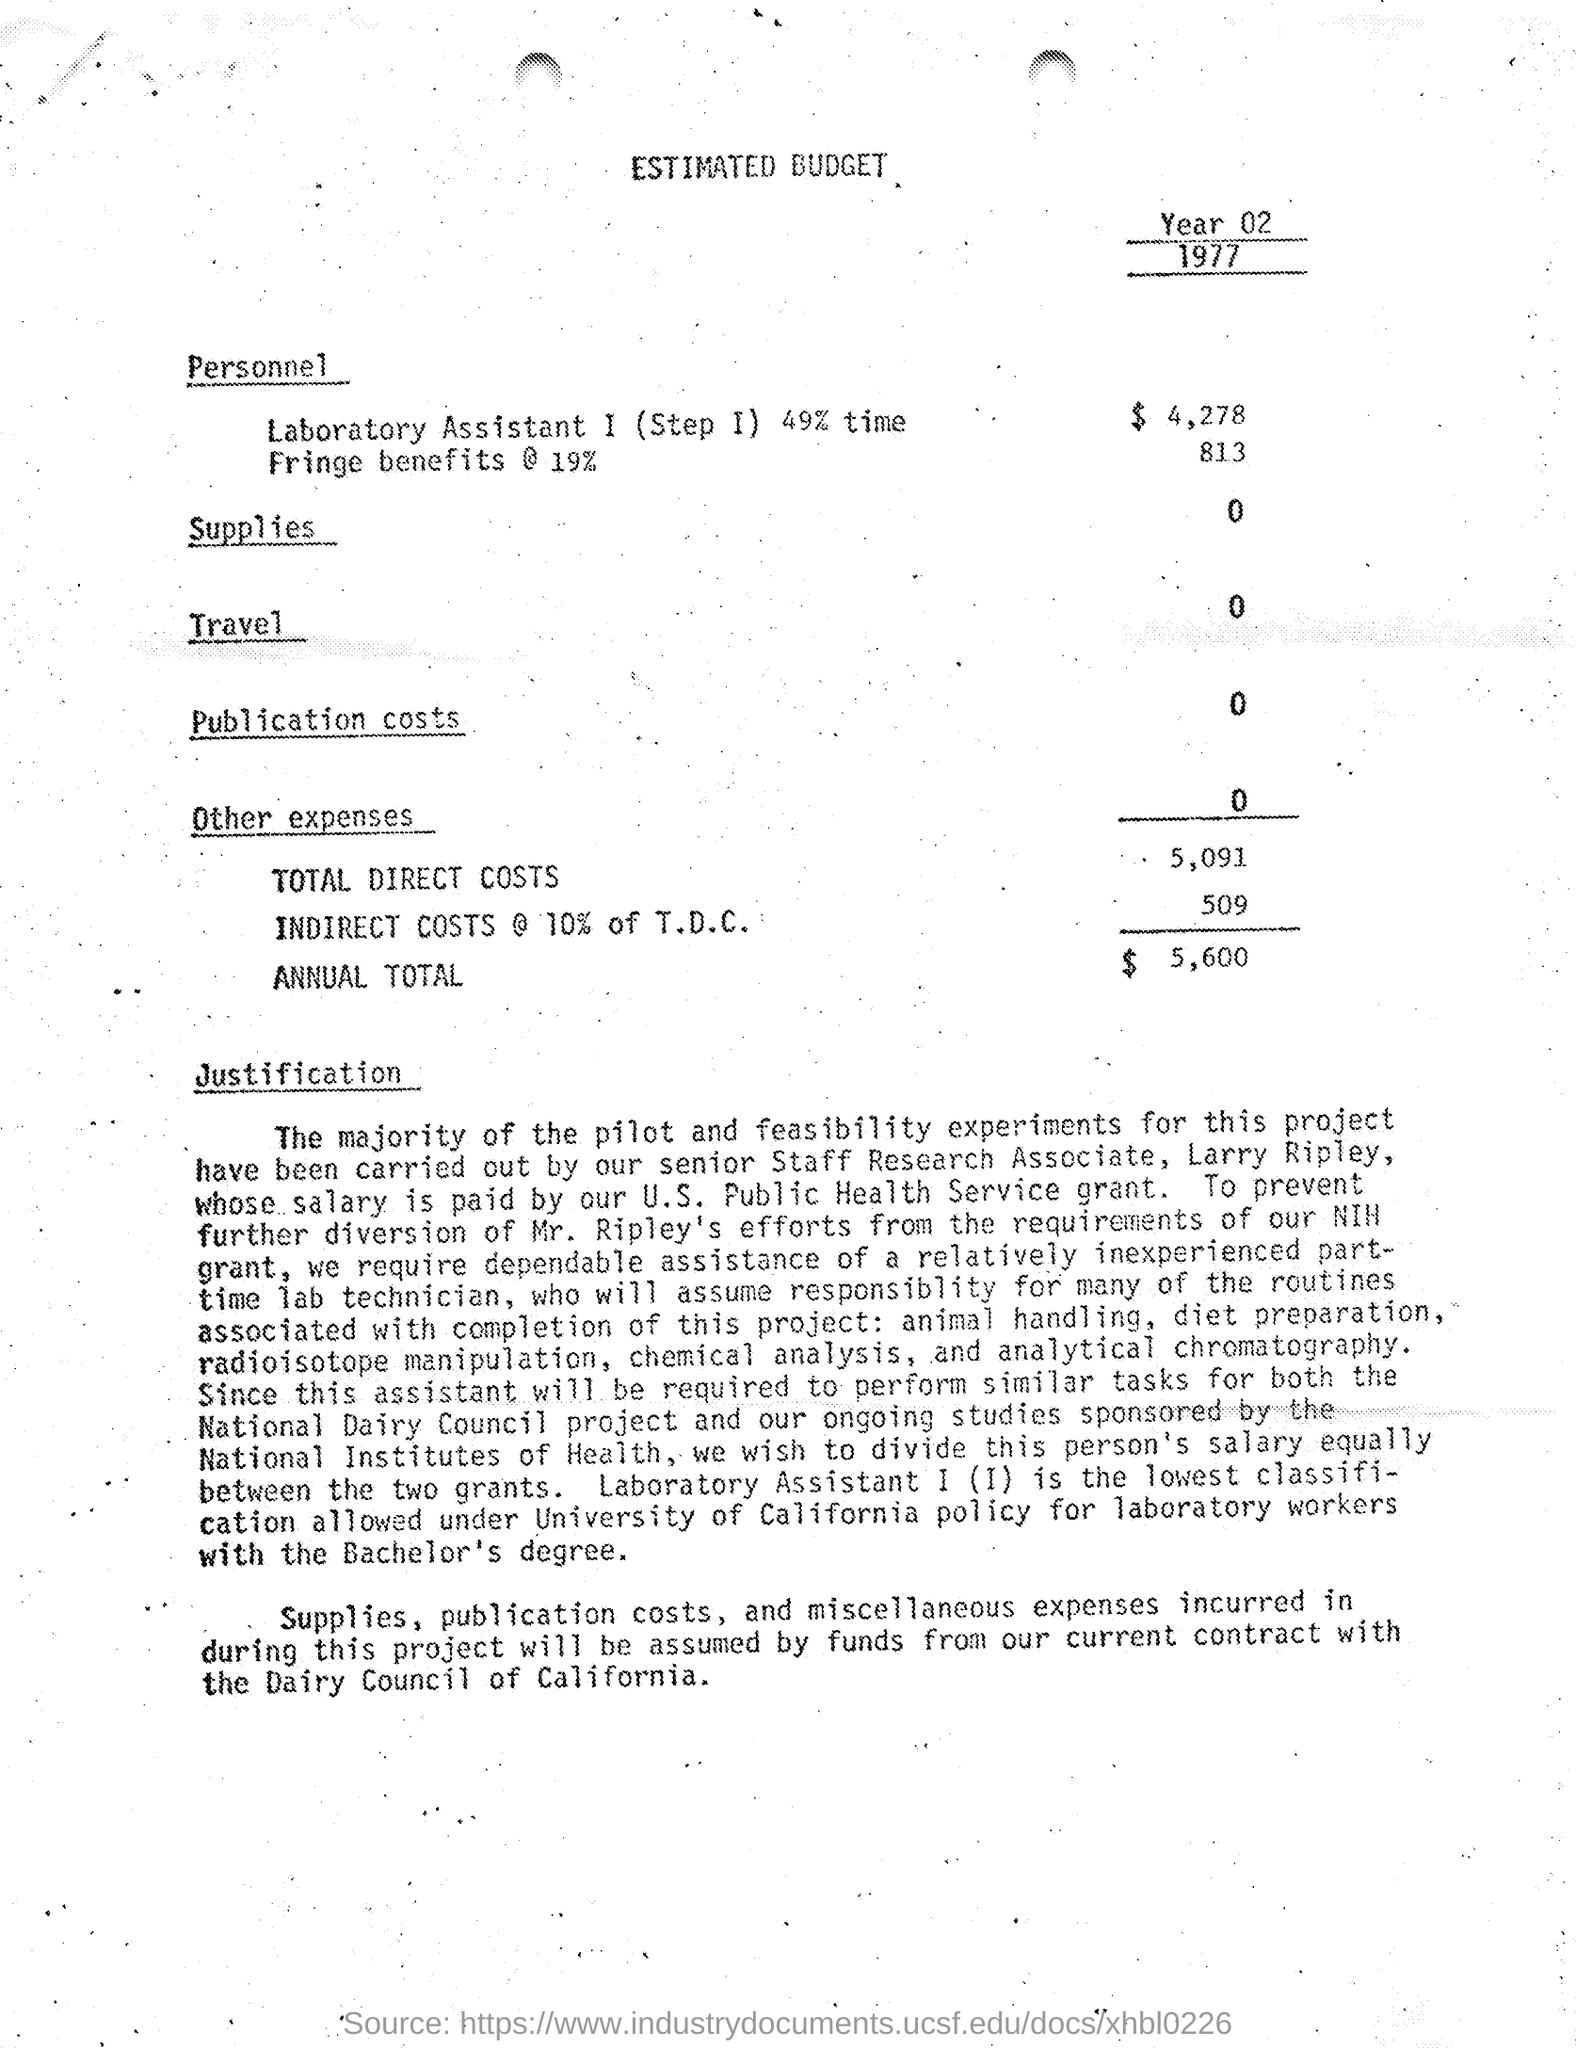Can you tell me what's the total of the indirect costs? The indirect costs are calculated as 10% of the Total Direct Costs (T.D.C.), which totals $509, as indicated under the 'INDIRECT COSTS' line. 